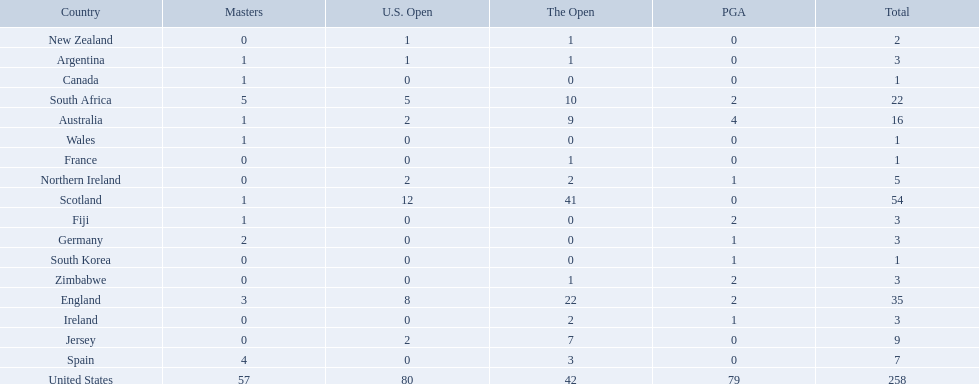What countries in the championship were from africa? South Africa, Zimbabwe. Which of these counteries had the least championship golfers Zimbabwe. 